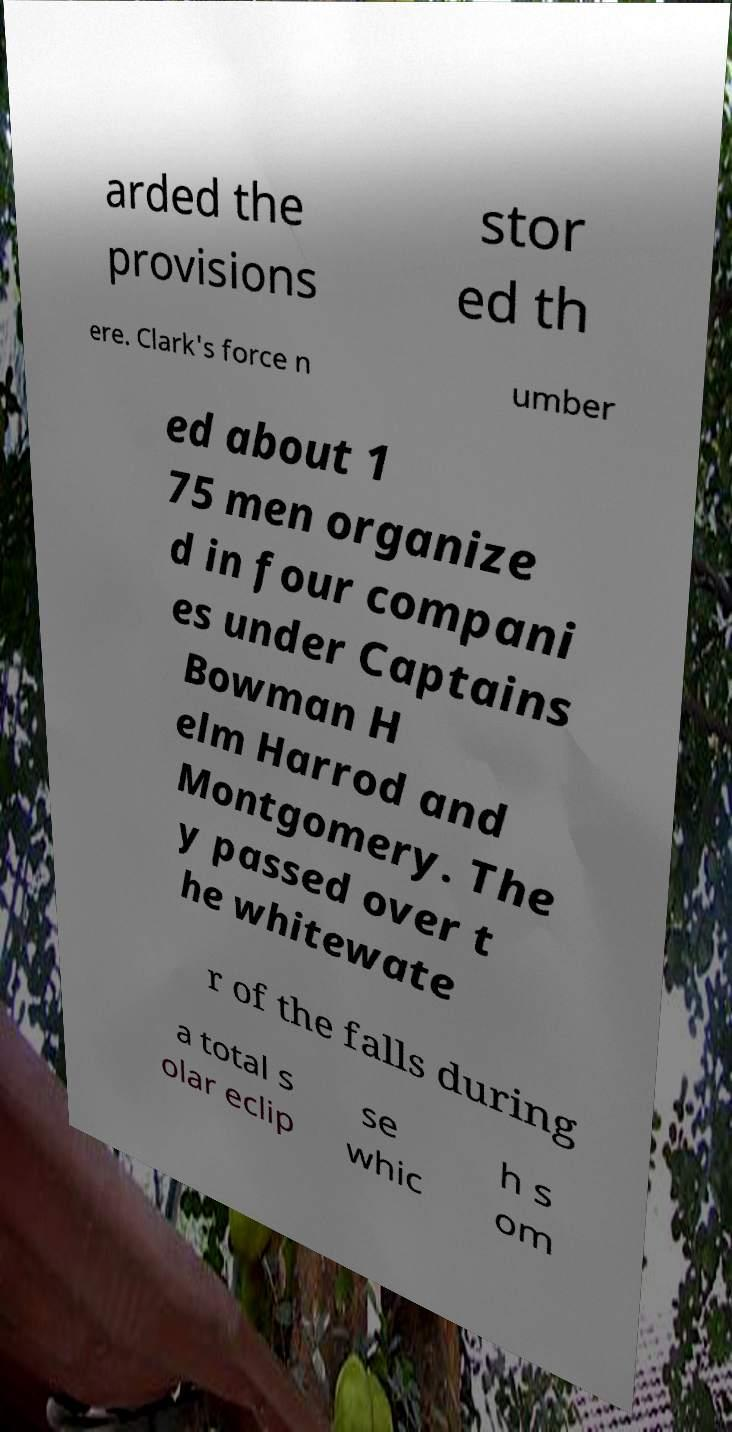I need the written content from this picture converted into text. Can you do that? arded the provisions stor ed th ere. Clark's force n umber ed about 1 75 men organize d in four compani es under Captains Bowman H elm Harrod and Montgomery. The y passed over t he whitewate r of the falls during a total s olar eclip se whic h s om 